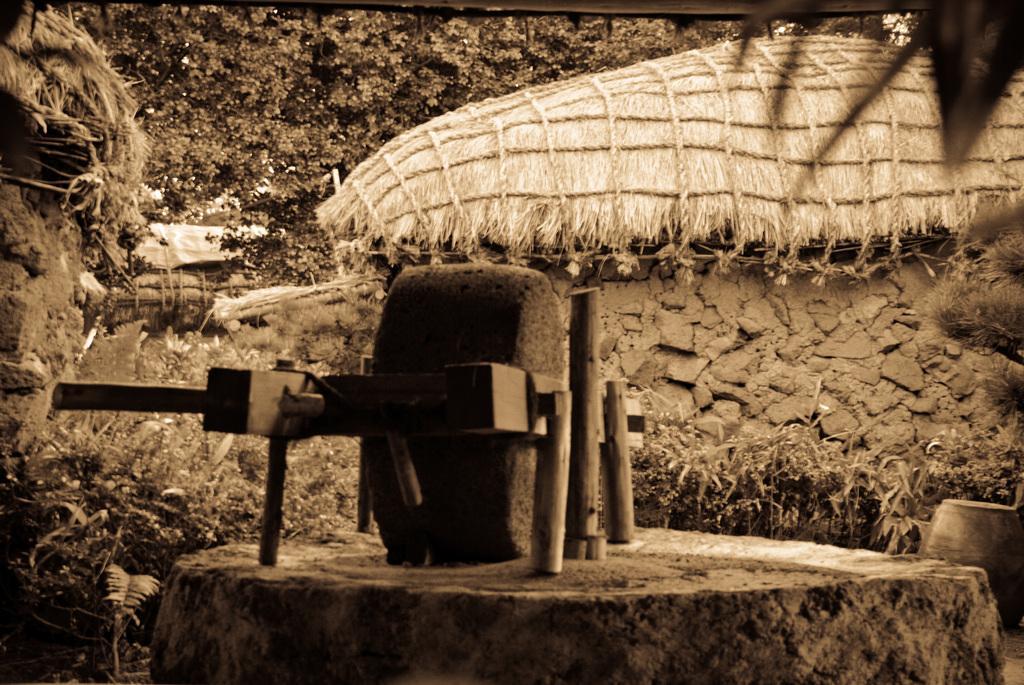Can you describe this image briefly? In the image we can see there is a stone wheel kept on the wooden stand and the object is kept on the rock. Behind there are huts and there are trees. The image is in black and white colour. 